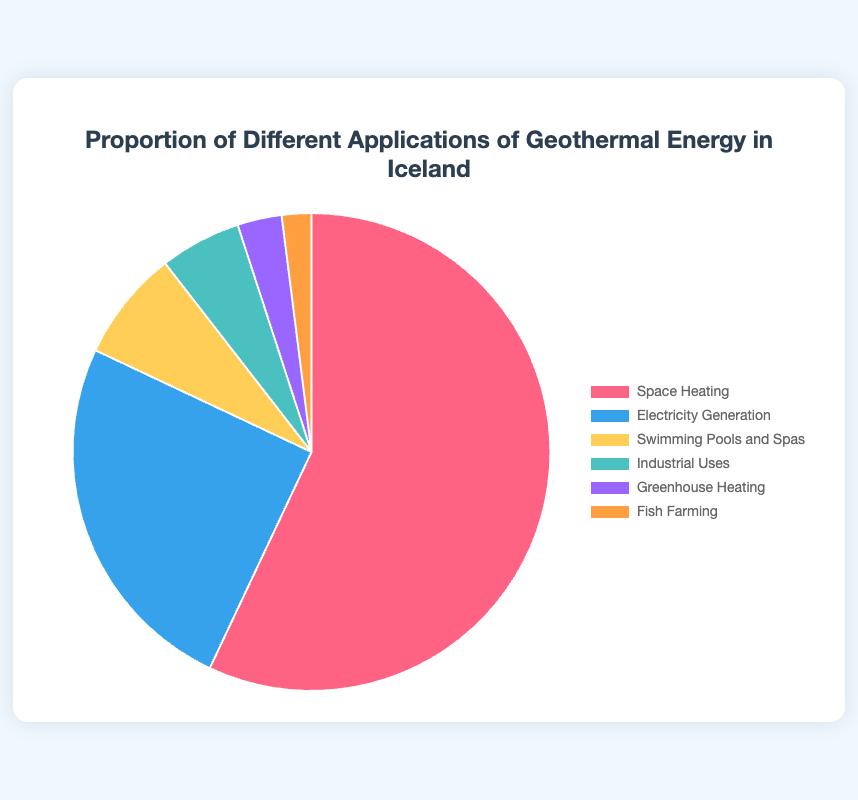What's the largest application of geothermal energy in Iceland? Space Heating takes 57.0% of the total geothermal energy application, which is the largest proportion among all categories displayed in the pie chart.
Answer: Space Heating How much more geothermal energy is used for space heating than electricity generation? Electricity Generation uses 25.0%. The difference between Space Heating (57.0%) and Electricity Generation (25.0%) is 57.0 - 25.0 = 32.0%.
Answer: 32.0% What percentage of geothermal energy is used for industrial purposes, swimming pools and spas combined? Industrial Uses consume 5.5% and Swimming Pools and Spas take 7.5%. The combined consumption is 5.5% + 7.5% = 13.0%.
Answer: 13.0% What's the smallest application of geothermal energy depicted in the figure? Fish Farming utilizes 2.0% of geothermal energy, which is the smallest proportion among all the categories presented in the pie chart.
Answer: Fish Farming Compare the energy used for Fish Farming and Greenhouse Heating. Which one is greater and by how much? Greenhouse Heating gets 3.0% while Fish Farming uses 2.0%. The difference is 3.0% - 2.0% = 1.0%, making Greenhouse Heating greater.
Answer: Greenhouse Heating by 1.0% What's the total percentage of geothermal energy used in non-electrical applications? Non-electrical applications include Space Heating (57.0%), Swimming Pools and Spas (7.5%), Industrial Uses (5.5%), Greenhouse Heating (3.0%), and Fish Farming (2.0%). Adding them gives: 57.0 + 7.5 + 5.5 + 3.0 + 2.0 = 75.0%.
Answer: 75.0% If we exclude Space Heating, what proportion of geothermal energy is used for other purposes? The total percentage for applications excluding Space Heating is 100% - 57.0% = 43.0%. This accounts for all other applications combined.
Answer: 43.0% What's the combined usage percentage of Greenhouse Heating and Fish Farming compared to Swimming Pools and Spas? Greenhouse Heating (3.0%) and Fish Farming (2.0%) together amount to 3.0% + 2.0% = 5.0%. Swimming Pools and Spas alone use 7.5%. Thus, 5.0% compared to 7.5% means Swimming Pools and Spas have a higher proportion.
Answer: 5.0% compared to 7.5%, lower 